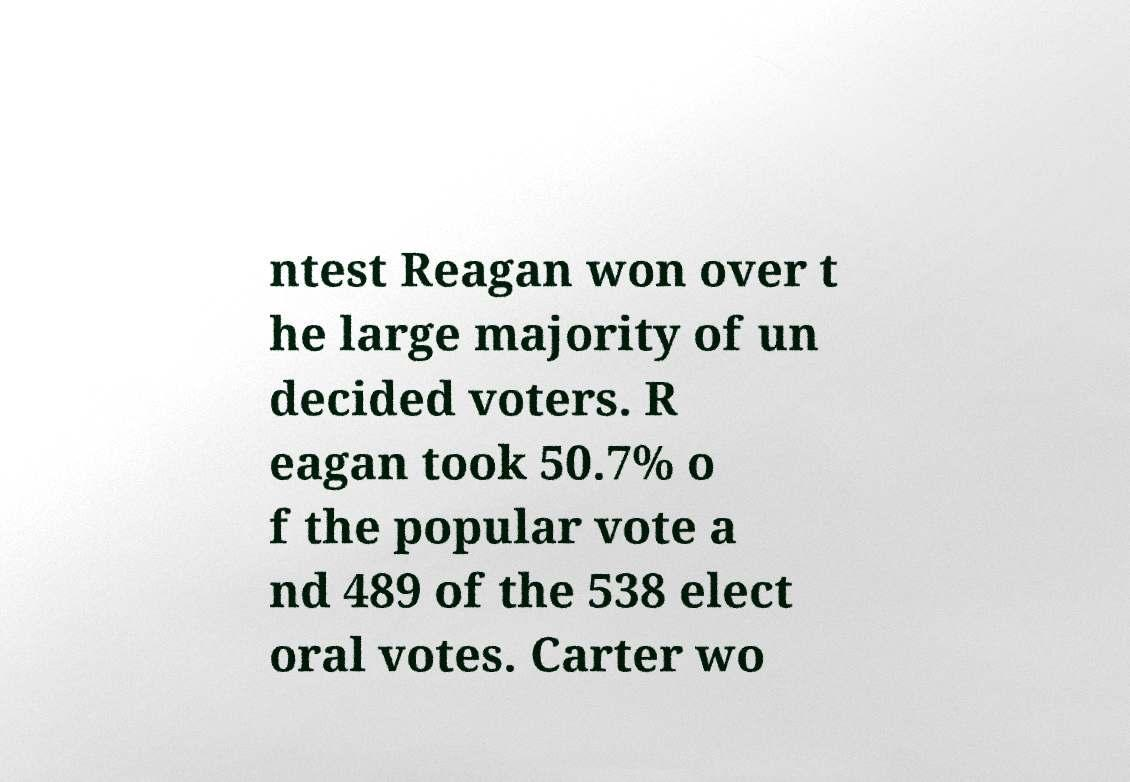Please identify and transcribe the text found in this image. ntest Reagan won over t he large majority of un decided voters. R eagan took 50.7% o f the popular vote a nd 489 of the 538 elect oral votes. Carter wo 